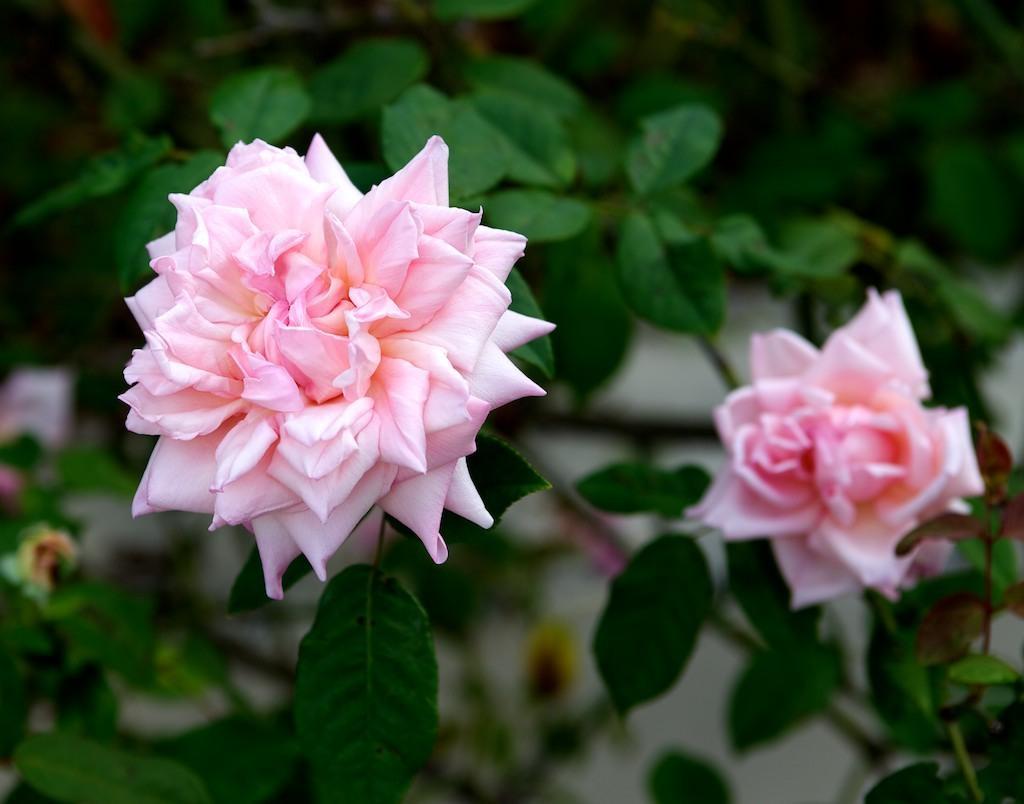How would you summarize this image in a sentence or two? In this picture there are light pink rose flowers on the plant. At the back there's a wall. 